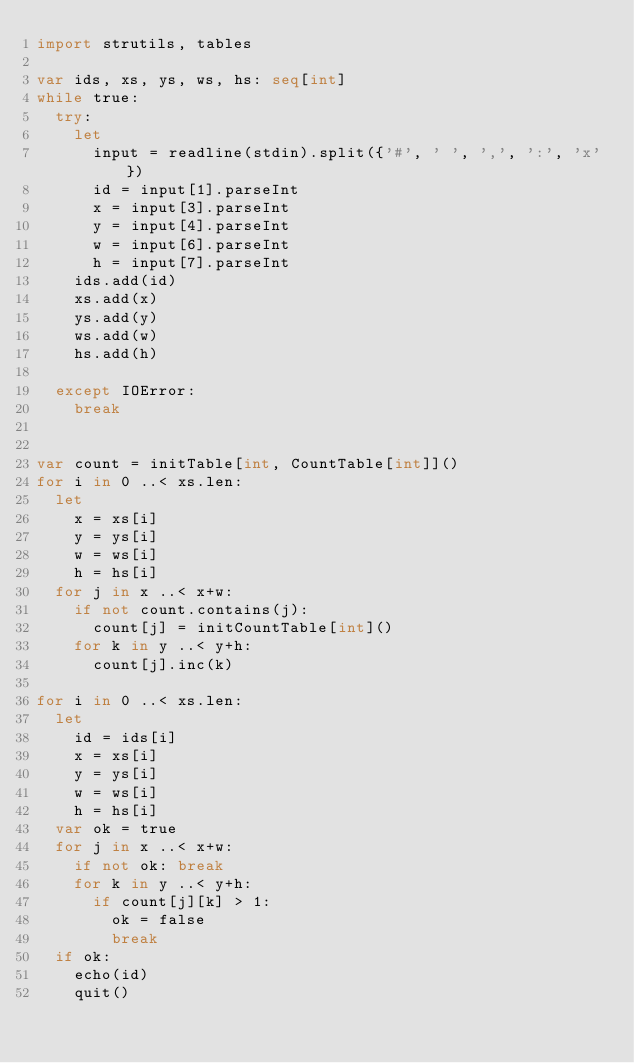<code> <loc_0><loc_0><loc_500><loc_500><_Nim_>import strutils, tables

var ids, xs, ys, ws, hs: seq[int]
while true:
  try:
    let
      input = readline(stdin).split({'#', ' ', ',', ':', 'x'})
      id = input[1].parseInt
      x = input[3].parseInt
      y = input[4].parseInt
      w = input[6].parseInt
      h = input[7].parseInt
    ids.add(id)
    xs.add(x)
    ys.add(y)
    ws.add(w)
    hs.add(h)

  except IOError:
    break


var count = initTable[int, CountTable[int]]()
for i in 0 ..< xs.len:
  let
    x = xs[i]
    y = ys[i]
    w = ws[i]
    h = hs[i]
  for j in x ..< x+w:
    if not count.contains(j):
      count[j] = initCountTable[int]()
    for k in y ..< y+h:
      count[j].inc(k)

for i in 0 ..< xs.len:
  let
    id = ids[i]
    x = xs[i]
    y = ys[i]
    w = ws[i]
    h = hs[i]
  var ok = true
  for j in x ..< x+w:
    if not ok: break
    for k in y ..< y+h:
      if count[j][k] > 1:
        ok = false
        break
  if ok:
    echo(id)
    quit()
</code> 